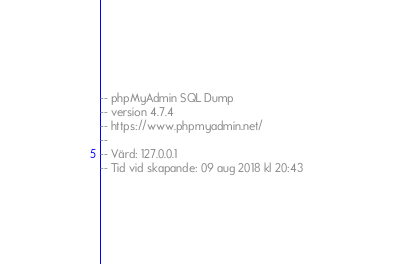<code> <loc_0><loc_0><loc_500><loc_500><_SQL_>-- phpMyAdmin SQL Dump
-- version 4.7.4
-- https://www.phpmyadmin.net/
--
-- Värd: 127.0.0.1
-- Tid vid skapande: 09 aug 2018 kl 20:43</code> 